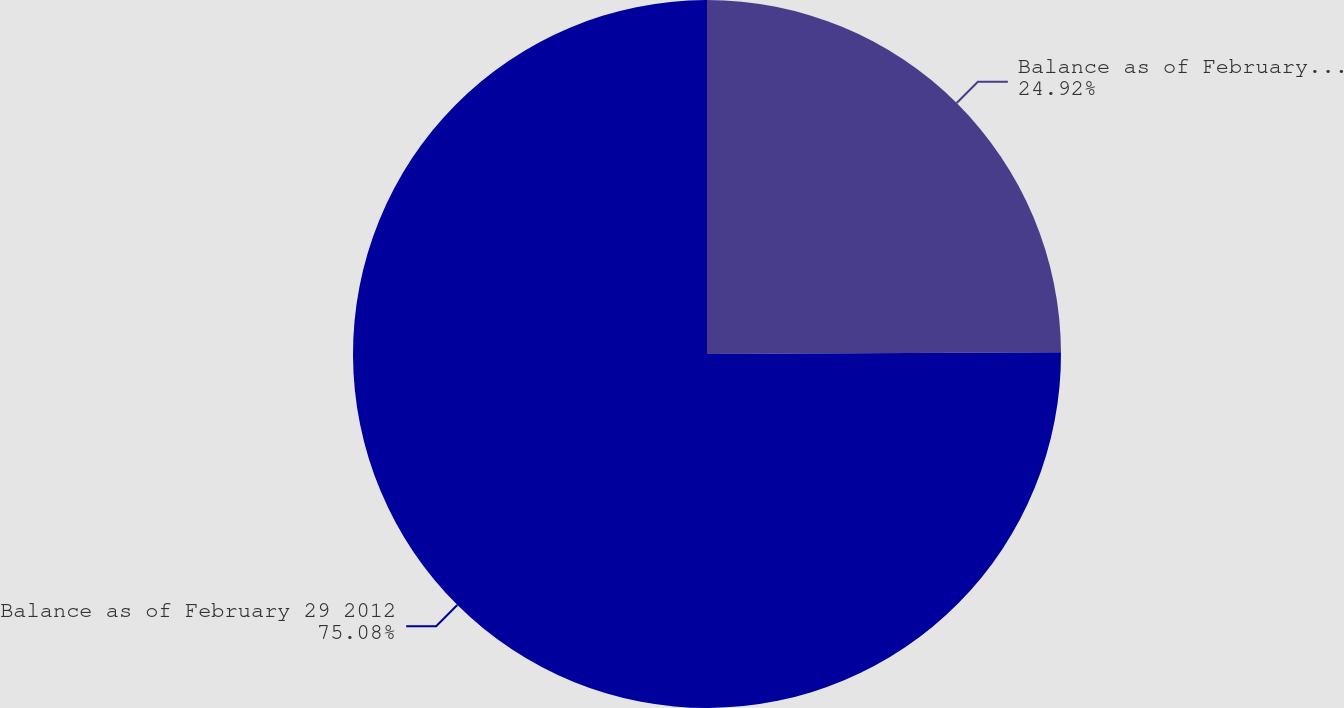<chart> <loc_0><loc_0><loc_500><loc_500><pie_chart><fcel>Balance as of February 28 2011<fcel>Balance as of February 29 2012<nl><fcel>24.92%<fcel>75.08%<nl></chart> 